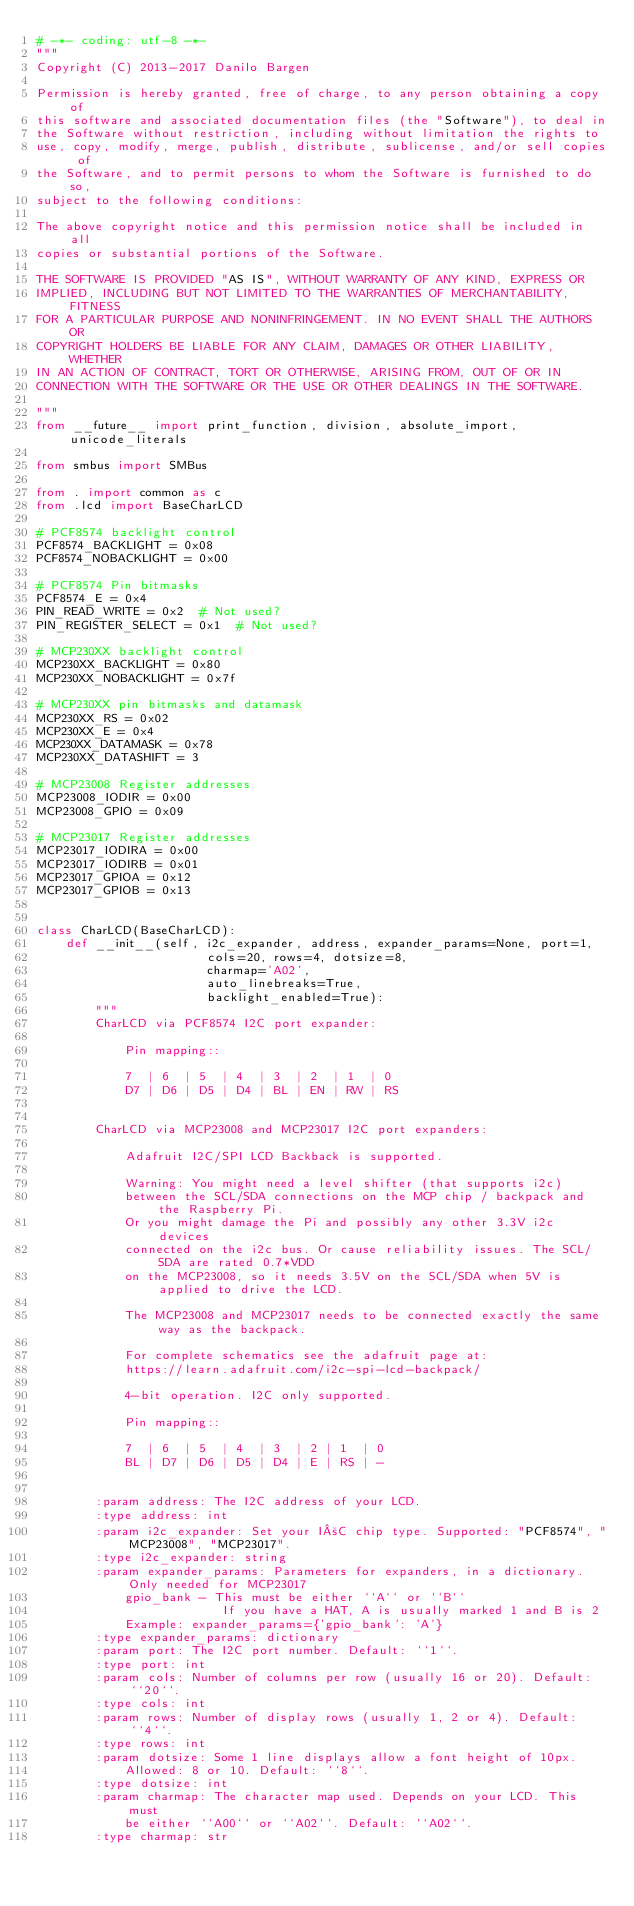Convert code to text. <code><loc_0><loc_0><loc_500><loc_500><_Python_># -*- coding: utf-8 -*-
"""
Copyright (C) 2013-2017 Danilo Bargen

Permission is hereby granted, free of charge, to any person obtaining a copy of
this software and associated documentation files (the "Software"), to deal in
the Software without restriction, including without limitation the rights to
use, copy, modify, merge, publish, distribute, sublicense, and/or sell copies of
the Software, and to permit persons to whom the Software is furnished to do so,
subject to the following conditions:

The above copyright notice and this permission notice shall be included in all
copies or substantial portions of the Software.

THE SOFTWARE IS PROVIDED "AS IS", WITHOUT WARRANTY OF ANY KIND, EXPRESS OR
IMPLIED, INCLUDING BUT NOT LIMITED TO THE WARRANTIES OF MERCHANTABILITY, FITNESS
FOR A PARTICULAR PURPOSE AND NONINFRINGEMENT. IN NO EVENT SHALL THE AUTHORS OR
COPYRIGHT HOLDERS BE LIABLE FOR ANY CLAIM, DAMAGES OR OTHER LIABILITY, WHETHER
IN AN ACTION OF CONTRACT, TORT OR OTHERWISE, ARISING FROM, OUT OF OR IN
CONNECTION WITH THE SOFTWARE OR THE USE OR OTHER DEALINGS IN THE SOFTWARE.

"""
from __future__ import print_function, division, absolute_import, unicode_literals

from smbus import SMBus

from . import common as c
from .lcd import BaseCharLCD

# PCF8574 backlight control
PCF8574_BACKLIGHT = 0x08
PCF8574_NOBACKLIGHT = 0x00

# PCF8574 Pin bitmasks
PCF8574_E = 0x4
PIN_READ_WRITE = 0x2  # Not used?
PIN_REGISTER_SELECT = 0x1  # Not used?

# MCP230XX backlight control
MCP230XX_BACKLIGHT = 0x80
MCP230XX_NOBACKLIGHT = 0x7f

# MCP230XX pin bitmasks and datamask
MCP230XX_RS = 0x02
MCP230XX_E = 0x4
MCP230XX_DATAMASK = 0x78
MCP230XX_DATASHIFT = 3

# MCP23008 Register addresses
MCP23008_IODIR = 0x00
MCP23008_GPIO = 0x09

# MCP23017 Register addresses
MCP23017_IODIRA = 0x00
MCP23017_IODIRB = 0x01
MCP23017_GPIOA = 0x12
MCP23017_GPIOB = 0x13


class CharLCD(BaseCharLCD):
    def __init__(self, i2c_expander, address, expander_params=None, port=1,
                       cols=20, rows=4, dotsize=8,
                       charmap='A02',
                       auto_linebreaks=True,
                       backlight_enabled=True):
        """
        CharLCD via PCF8574 I2C port expander:

            Pin mapping::

            7  | 6  | 5  | 4  | 3  | 2  | 1  | 0
            D7 | D6 | D5 | D4 | BL | EN | RW | RS


        CharLCD via MCP23008 and MCP23017 I2C port expanders:

            Adafruit I2C/SPI LCD Backback is supported.

            Warning: You might need a level shifter (that supports i2c)
            between the SCL/SDA connections on the MCP chip / backpack and the Raspberry Pi.
            Or you might damage the Pi and possibly any other 3.3V i2c devices
            connected on the i2c bus. Or cause reliability issues. The SCL/SDA are rated 0.7*VDD
            on the MCP23008, so it needs 3.5V on the SCL/SDA when 5V is applied to drive the LCD.

            The MCP23008 and MCP23017 needs to be connected exactly the same way as the backpack.

            For complete schematics see the adafruit page at:
            https://learn.adafruit.com/i2c-spi-lcd-backpack/

            4-bit operation. I2C only supported.

            Pin mapping::

            7  | 6  | 5  | 4  | 3  | 2 | 1  | 0
            BL | D7 | D6 | D5 | D4 | E | RS | -


        :param address: The I2C address of your LCD.
        :type address: int
        :param i2c_expander: Set your I²C chip type. Supported: "PCF8574", "MCP23008", "MCP23017".
        :type i2c_expander: string
        :param expander_params: Parameters for expanders, in a dictionary. Only needed for MCP23017
            gpio_bank - This must be either ``A`` or ``B``
                         If you have a HAT, A is usually marked 1 and B is 2
            Example: expander_params={'gpio_bank': 'A'}
        :type expander_params: dictionary
        :param port: The I2C port number. Default: ``1``.
        :type port: int
        :param cols: Number of columns per row (usually 16 or 20). Default: ``20``.
        :type cols: int
        :param rows: Number of display rows (usually 1, 2 or 4). Default: ``4``.
        :type rows: int
        :param dotsize: Some 1 line displays allow a font height of 10px.
            Allowed: 8 or 10. Default: ``8``.
        :type dotsize: int
        :param charmap: The character map used. Depends on your LCD. This must
            be either ``A00`` or ``A02``. Default: ``A02``.
        :type charmap: str</code> 